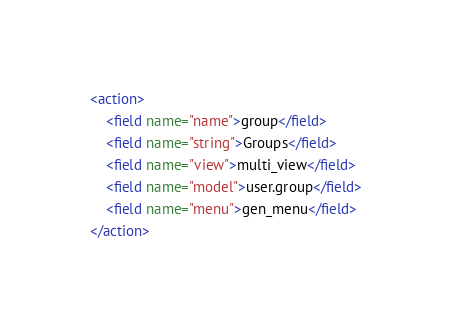<code> <loc_0><loc_0><loc_500><loc_500><_XML_><action>
    <field name="name">group</field>
    <field name="string">Groups</field>
    <field name="view">multi_view</field>
    <field name="model">user.group</field>
    <field name="menu">gen_menu</field>
</action>
</code> 